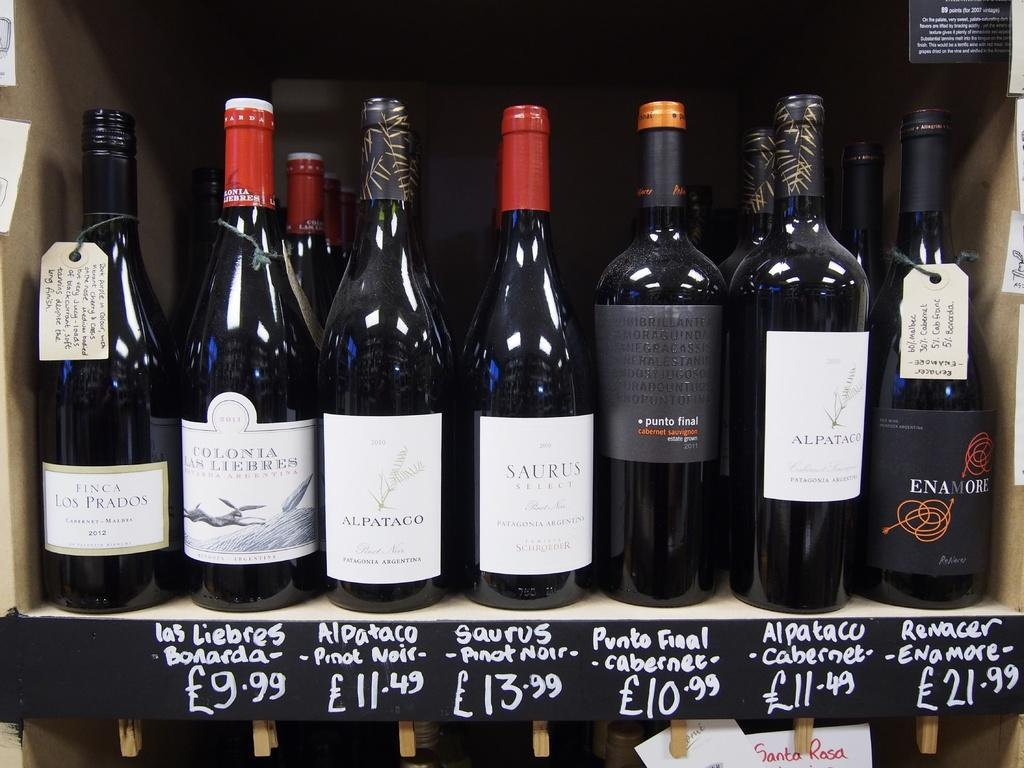Provide a one-sentence caption for the provided image. Bottles of wine sit on a shelf with the prices listed underneath them which one says it 10.99. 